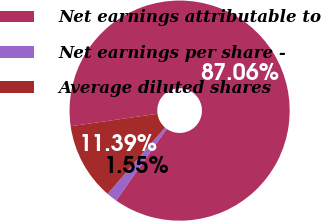Convert chart to OTSL. <chart><loc_0><loc_0><loc_500><loc_500><pie_chart><fcel>Net earnings attributable to<fcel>Net earnings per share -<fcel>Average diluted shares<nl><fcel>87.05%<fcel>1.55%<fcel>11.39%<nl></chart> 